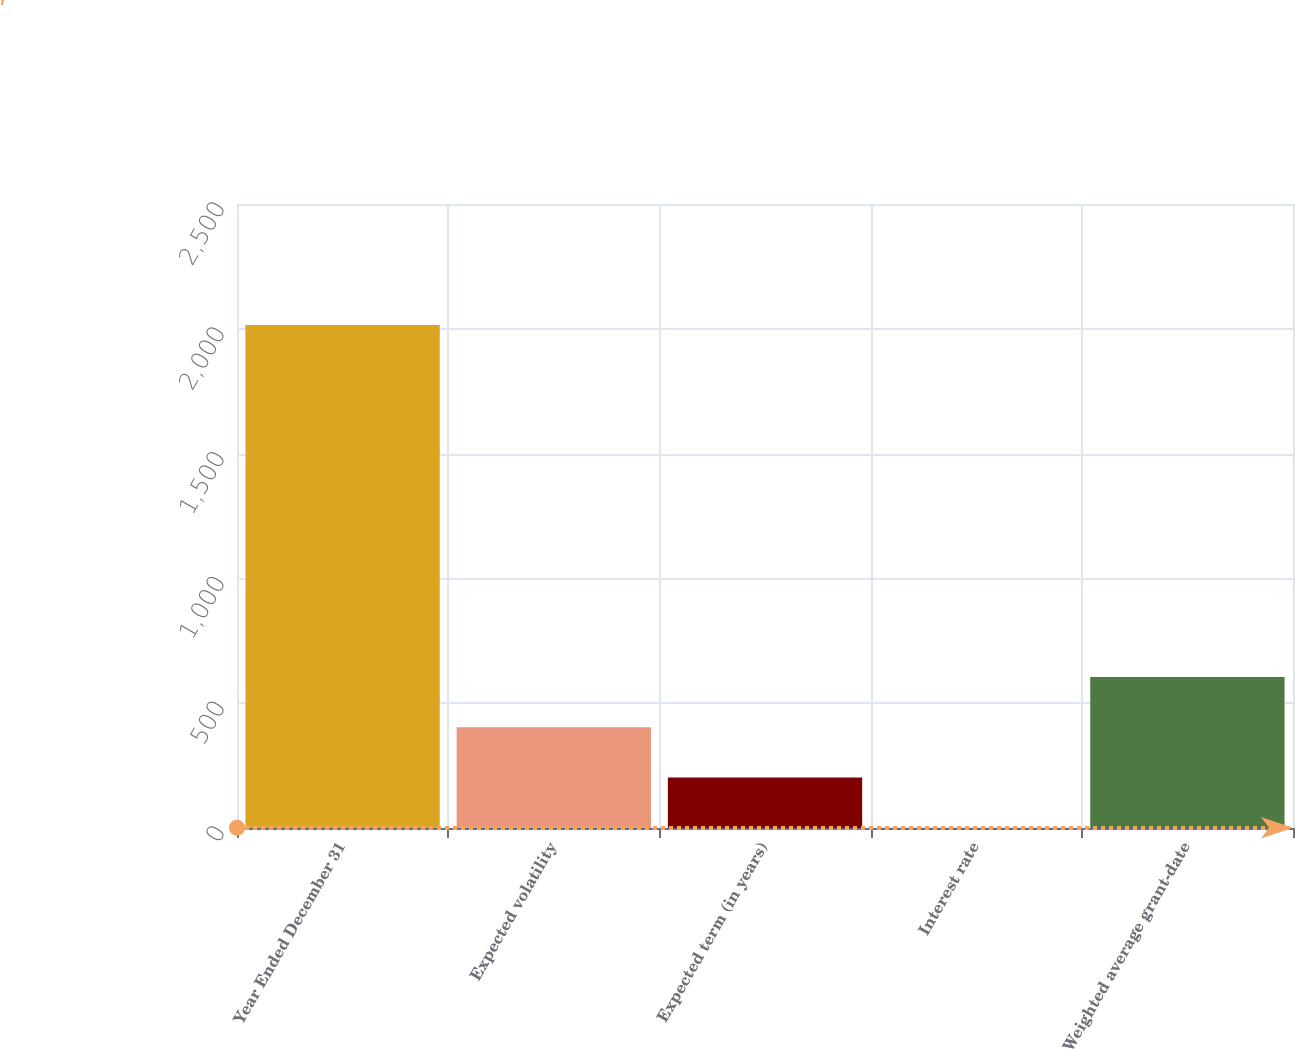Convert chart. <chart><loc_0><loc_0><loc_500><loc_500><bar_chart><fcel>Year Ended December 31<fcel>Expected volatility<fcel>Expected term (in years)<fcel>Interest rate<fcel>Weighted average grant-date<nl><fcel>2015<fcel>403.8<fcel>202.4<fcel>1<fcel>605.2<nl></chart> 